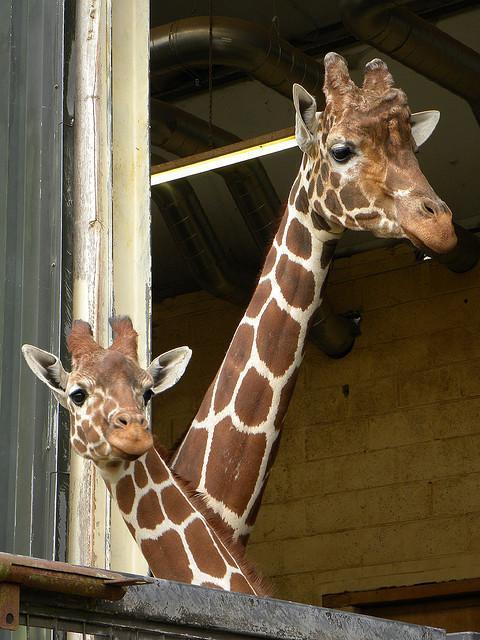How many animals are shown?
Give a very brief answer. 2. How many giraffes are there?
Give a very brief answer. 2. 